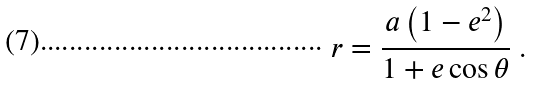Convert formula to latex. <formula><loc_0><loc_0><loc_500><loc_500>r = { \frac { a \left ( 1 - e ^ { 2 } \right ) } { 1 + e \cos \theta } } \ .</formula> 